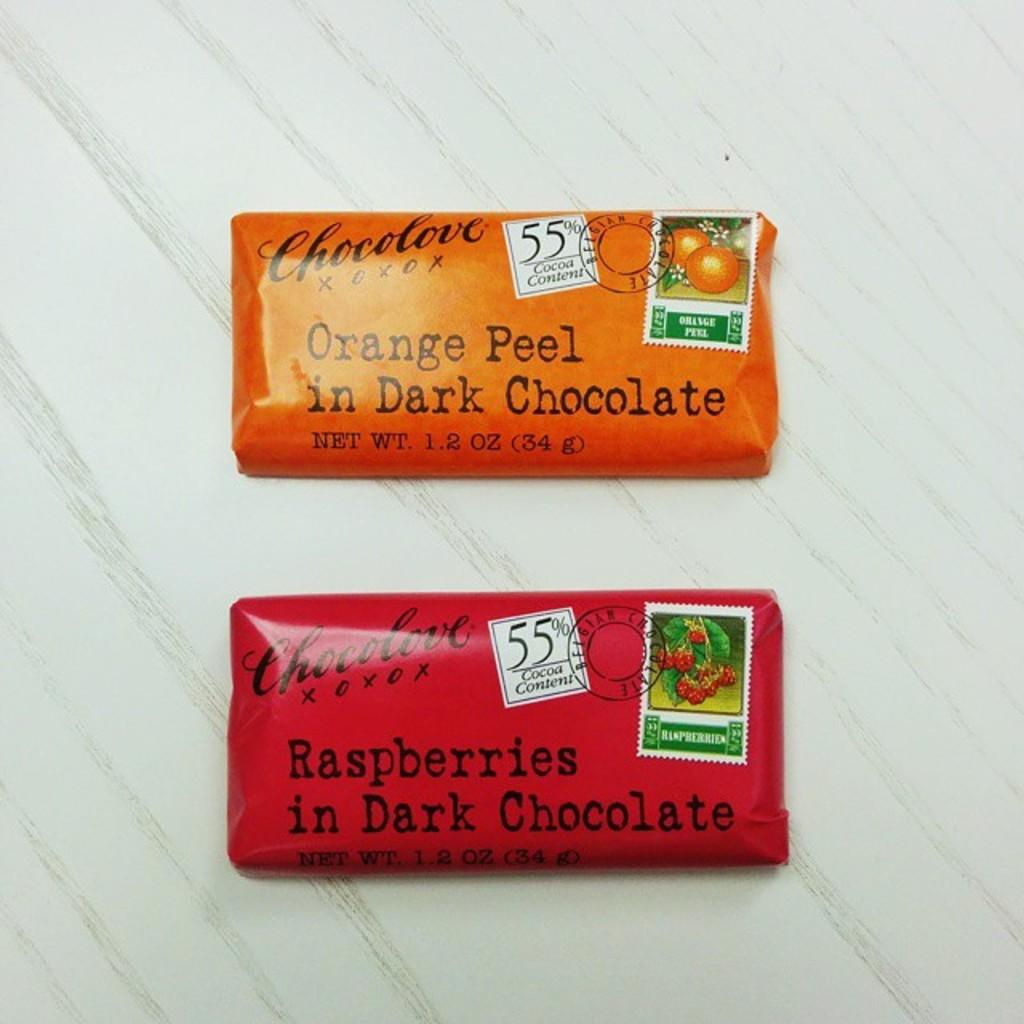<image>
Present a compact description of the photo's key features. Two colorful bars of chocolate are very affectionate and probably delicious. 